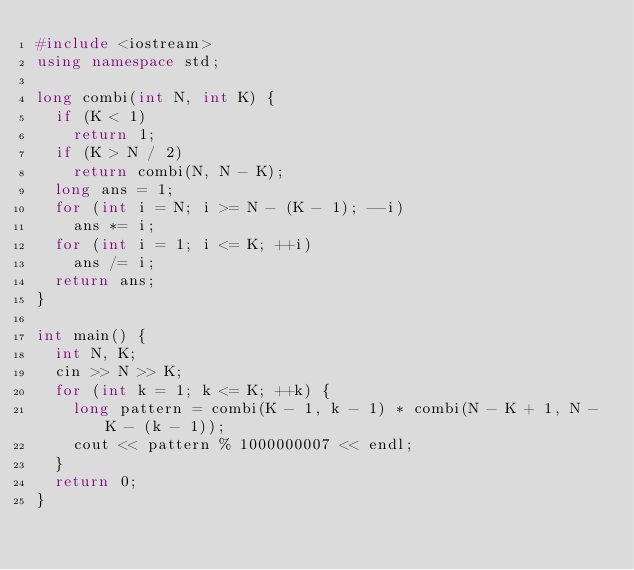<code> <loc_0><loc_0><loc_500><loc_500><_C++_>#include <iostream>
using namespace std;

long combi(int N, int K) {
  if (K < 1)
    return 1;
  if (K > N / 2)
    return combi(N, N - K);
  long ans = 1;
  for (int i = N; i >= N - (K - 1); --i)
    ans *= i;
  for (int i = 1; i <= K; ++i)
    ans /= i;
  return ans;
}

int main() {
  int N, K;
  cin >> N >> K;
  for (int k = 1; k <= K; ++k) {
    long pattern = combi(K - 1, k - 1) * combi(N - K + 1, N - K - (k - 1));
    cout << pattern % 1000000007 << endl;
  }
  return 0;
}</code> 